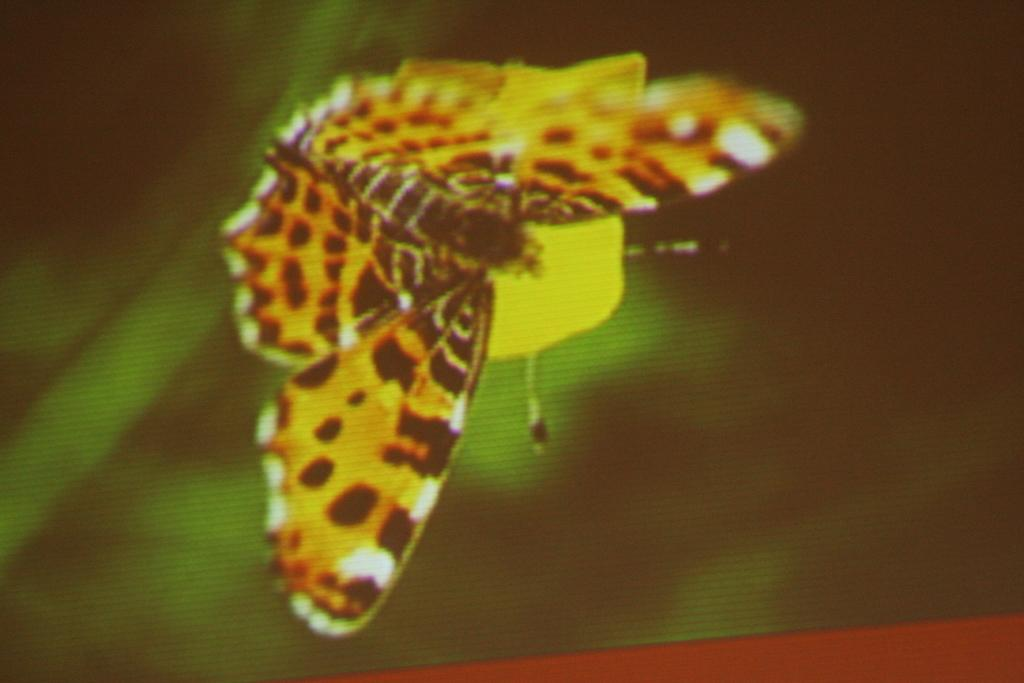What is the main subject of the image? There is a butterfly in the image. Can you describe the background of the image? The background of the image is blurred. What type of religious symbol can be seen in the image? There is no religious symbol present in the image; it features a butterfly and a blurred background. How many bushes are visible in the image? There are no bushes visible in the image; it features a butterfly and a blurred background. 